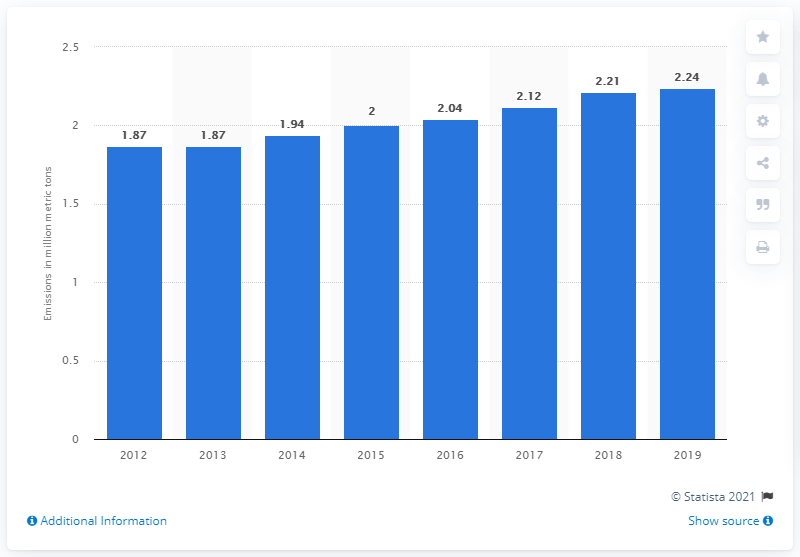Mention a couple of crucial points in this snapshot. In 2019, the total amount of carbon monoxide emissions in Malaysia was 2.24. 